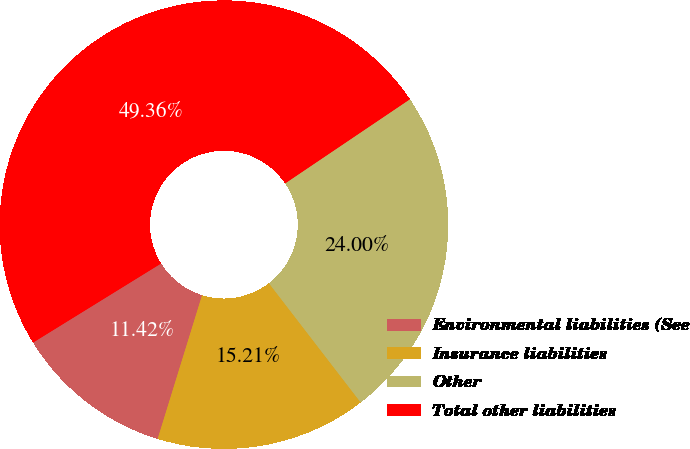Convert chart to OTSL. <chart><loc_0><loc_0><loc_500><loc_500><pie_chart><fcel>Environmental liabilities (See<fcel>Insurance liabilities<fcel>Other<fcel>Total other liabilities<nl><fcel>11.42%<fcel>15.21%<fcel>24.0%<fcel>49.36%<nl></chart> 